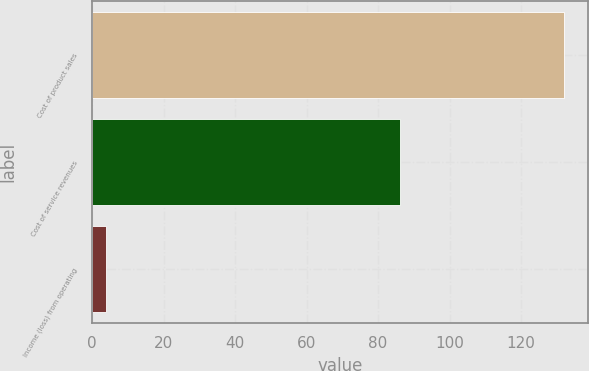<chart> <loc_0><loc_0><loc_500><loc_500><bar_chart><fcel>Cost of product sales<fcel>Cost of service revenues<fcel>Income (loss) from operating<nl><fcel>132<fcel>86<fcel>4<nl></chart> 